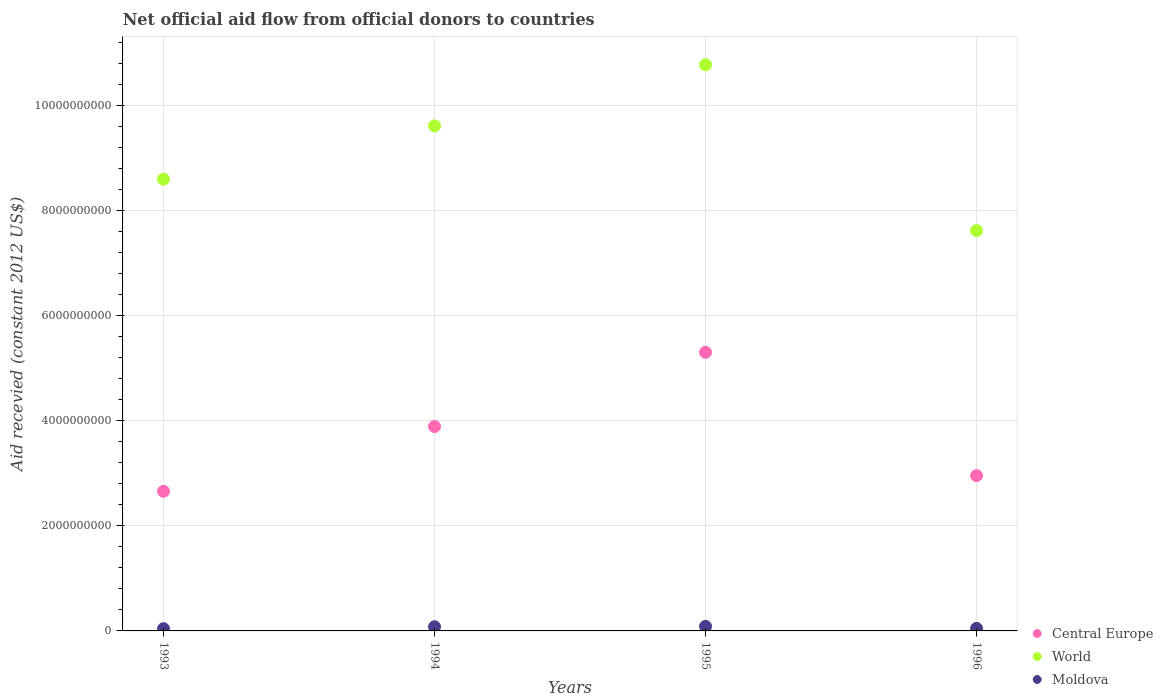How many different coloured dotlines are there?
Give a very brief answer. 3. What is the total aid received in Moldova in 1995?
Offer a very short reply. 8.72e+07. Across all years, what is the maximum total aid received in Moldova?
Make the answer very short. 8.72e+07. Across all years, what is the minimum total aid received in World?
Make the answer very short. 7.62e+09. In which year was the total aid received in World maximum?
Ensure brevity in your answer.  1995. In which year was the total aid received in World minimum?
Offer a very short reply. 1996. What is the total total aid received in World in the graph?
Your response must be concise. 3.66e+1. What is the difference between the total aid received in Central Europe in 1993 and that in 1996?
Make the answer very short. -2.98e+08. What is the difference between the total aid received in World in 1993 and the total aid received in Central Europe in 1994?
Ensure brevity in your answer.  4.71e+09. What is the average total aid received in Central Europe per year?
Give a very brief answer. 3.70e+09. In the year 1994, what is the difference between the total aid received in Moldova and total aid received in Central Europe?
Your answer should be compact. -3.81e+09. In how many years, is the total aid received in Central Europe greater than 3200000000 US$?
Your answer should be compact. 2. What is the ratio of the total aid received in World in 1994 to that in 1996?
Offer a terse response. 1.26. What is the difference between the highest and the second highest total aid received in Central Europe?
Offer a terse response. 1.41e+09. What is the difference between the highest and the lowest total aid received in Moldova?
Your response must be concise. 4.48e+07. In how many years, is the total aid received in Moldova greater than the average total aid received in Moldova taken over all years?
Ensure brevity in your answer.  2. Is the sum of the total aid received in World in 1993 and 1996 greater than the maximum total aid received in Moldova across all years?
Offer a very short reply. Yes. Does the total aid received in Moldova monotonically increase over the years?
Offer a very short reply. No. Is the total aid received in Central Europe strictly greater than the total aid received in Moldova over the years?
Offer a very short reply. Yes. How many years are there in the graph?
Your answer should be compact. 4. What is the difference between two consecutive major ticks on the Y-axis?
Keep it short and to the point. 2.00e+09. Are the values on the major ticks of Y-axis written in scientific E-notation?
Keep it short and to the point. No. Does the graph contain grids?
Offer a terse response. Yes. Where does the legend appear in the graph?
Your answer should be very brief. Bottom right. How many legend labels are there?
Provide a short and direct response. 3. How are the legend labels stacked?
Your answer should be compact. Vertical. What is the title of the graph?
Your answer should be very brief. Net official aid flow from official donors to countries. What is the label or title of the Y-axis?
Give a very brief answer. Aid recevied (constant 2012 US$). What is the Aid recevied (constant 2012 US$) in Central Europe in 1993?
Provide a short and direct response. 2.66e+09. What is the Aid recevied (constant 2012 US$) in World in 1993?
Make the answer very short. 8.60e+09. What is the Aid recevied (constant 2012 US$) in Moldova in 1993?
Your response must be concise. 4.23e+07. What is the Aid recevied (constant 2012 US$) in Central Europe in 1994?
Provide a succinct answer. 3.89e+09. What is the Aid recevied (constant 2012 US$) of World in 1994?
Your response must be concise. 9.61e+09. What is the Aid recevied (constant 2012 US$) in Moldova in 1994?
Ensure brevity in your answer.  7.92e+07. What is the Aid recevied (constant 2012 US$) of Central Europe in 1995?
Ensure brevity in your answer.  5.30e+09. What is the Aid recevied (constant 2012 US$) of World in 1995?
Your answer should be compact. 1.08e+1. What is the Aid recevied (constant 2012 US$) of Moldova in 1995?
Offer a very short reply. 8.72e+07. What is the Aid recevied (constant 2012 US$) in Central Europe in 1996?
Provide a succinct answer. 2.96e+09. What is the Aid recevied (constant 2012 US$) in World in 1996?
Give a very brief answer. 7.62e+09. What is the Aid recevied (constant 2012 US$) in Moldova in 1996?
Your answer should be very brief. 4.89e+07. Across all years, what is the maximum Aid recevied (constant 2012 US$) of Central Europe?
Make the answer very short. 5.30e+09. Across all years, what is the maximum Aid recevied (constant 2012 US$) of World?
Give a very brief answer. 1.08e+1. Across all years, what is the maximum Aid recevied (constant 2012 US$) in Moldova?
Provide a short and direct response. 8.72e+07. Across all years, what is the minimum Aid recevied (constant 2012 US$) in Central Europe?
Provide a short and direct response. 2.66e+09. Across all years, what is the minimum Aid recevied (constant 2012 US$) of World?
Your answer should be very brief. 7.62e+09. Across all years, what is the minimum Aid recevied (constant 2012 US$) of Moldova?
Keep it short and to the point. 4.23e+07. What is the total Aid recevied (constant 2012 US$) in Central Europe in the graph?
Provide a short and direct response. 1.48e+1. What is the total Aid recevied (constant 2012 US$) in World in the graph?
Give a very brief answer. 3.66e+1. What is the total Aid recevied (constant 2012 US$) in Moldova in the graph?
Provide a succinct answer. 2.57e+08. What is the difference between the Aid recevied (constant 2012 US$) in Central Europe in 1993 and that in 1994?
Give a very brief answer. -1.23e+09. What is the difference between the Aid recevied (constant 2012 US$) in World in 1993 and that in 1994?
Provide a short and direct response. -1.01e+09. What is the difference between the Aid recevied (constant 2012 US$) of Moldova in 1993 and that in 1994?
Offer a terse response. -3.68e+07. What is the difference between the Aid recevied (constant 2012 US$) of Central Europe in 1993 and that in 1995?
Provide a succinct answer. -2.64e+09. What is the difference between the Aid recevied (constant 2012 US$) of World in 1993 and that in 1995?
Your answer should be compact. -2.18e+09. What is the difference between the Aid recevied (constant 2012 US$) in Moldova in 1993 and that in 1995?
Your response must be concise. -4.48e+07. What is the difference between the Aid recevied (constant 2012 US$) in Central Europe in 1993 and that in 1996?
Offer a very short reply. -2.98e+08. What is the difference between the Aid recevied (constant 2012 US$) in World in 1993 and that in 1996?
Your response must be concise. 9.79e+08. What is the difference between the Aid recevied (constant 2012 US$) of Moldova in 1993 and that in 1996?
Make the answer very short. -6.56e+06. What is the difference between the Aid recevied (constant 2012 US$) in Central Europe in 1994 and that in 1995?
Provide a succinct answer. -1.41e+09. What is the difference between the Aid recevied (constant 2012 US$) in World in 1994 and that in 1995?
Offer a very short reply. -1.16e+09. What is the difference between the Aid recevied (constant 2012 US$) in Moldova in 1994 and that in 1995?
Keep it short and to the point. -8.00e+06. What is the difference between the Aid recevied (constant 2012 US$) of Central Europe in 1994 and that in 1996?
Provide a succinct answer. 9.34e+08. What is the difference between the Aid recevied (constant 2012 US$) of World in 1994 and that in 1996?
Offer a very short reply. 1.99e+09. What is the difference between the Aid recevied (constant 2012 US$) of Moldova in 1994 and that in 1996?
Ensure brevity in your answer.  3.03e+07. What is the difference between the Aid recevied (constant 2012 US$) in Central Europe in 1995 and that in 1996?
Make the answer very short. 2.35e+09. What is the difference between the Aid recevied (constant 2012 US$) in World in 1995 and that in 1996?
Keep it short and to the point. 3.16e+09. What is the difference between the Aid recevied (constant 2012 US$) in Moldova in 1995 and that in 1996?
Offer a terse response. 3.83e+07. What is the difference between the Aid recevied (constant 2012 US$) of Central Europe in 1993 and the Aid recevied (constant 2012 US$) of World in 1994?
Provide a short and direct response. -6.95e+09. What is the difference between the Aid recevied (constant 2012 US$) of Central Europe in 1993 and the Aid recevied (constant 2012 US$) of Moldova in 1994?
Offer a very short reply. 2.58e+09. What is the difference between the Aid recevied (constant 2012 US$) of World in 1993 and the Aid recevied (constant 2012 US$) of Moldova in 1994?
Offer a very short reply. 8.52e+09. What is the difference between the Aid recevied (constant 2012 US$) of Central Europe in 1993 and the Aid recevied (constant 2012 US$) of World in 1995?
Provide a succinct answer. -8.12e+09. What is the difference between the Aid recevied (constant 2012 US$) of Central Europe in 1993 and the Aid recevied (constant 2012 US$) of Moldova in 1995?
Ensure brevity in your answer.  2.57e+09. What is the difference between the Aid recevied (constant 2012 US$) of World in 1993 and the Aid recevied (constant 2012 US$) of Moldova in 1995?
Keep it short and to the point. 8.51e+09. What is the difference between the Aid recevied (constant 2012 US$) in Central Europe in 1993 and the Aid recevied (constant 2012 US$) in World in 1996?
Make the answer very short. -4.96e+09. What is the difference between the Aid recevied (constant 2012 US$) in Central Europe in 1993 and the Aid recevied (constant 2012 US$) in Moldova in 1996?
Keep it short and to the point. 2.61e+09. What is the difference between the Aid recevied (constant 2012 US$) in World in 1993 and the Aid recevied (constant 2012 US$) in Moldova in 1996?
Provide a short and direct response. 8.55e+09. What is the difference between the Aid recevied (constant 2012 US$) of Central Europe in 1994 and the Aid recevied (constant 2012 US$) of World in 1995?
Your answer should be very brief. -6.89e+09. What is the difference between the Aid recevied (constant 2012 US$) in Central Europe in 1994 and the Aid recevied (constant 2012 US$) in Moldova in 1995?
Offer a very short reply. 3.80e+09. What is the difference between the Aid recevied (constant 2012 US$) in World in 1994 and the Aid recevied (constant 2012 US$) in Moldova in 1995?
Offer a very short reply. 9.52e+09. What is the difference between the Aid recevied (constant 2012 US$) in Central Europe in 1994 and the Aid recevied (constant 2012 US$) in World in 1996?
Ensure brevity in your answer.  -3.73e+09. What is the difference between the Aid recevied (constant 2012 US$) in Central Europe in 1994 and the Aid recevied (constant 2012 US$) in Moldova in 1996?
Ensure brevity in your answer.  3.84e+09. What is the difference between the Aid recevied (constant 2012 US$) of World in 1994 and the Aid recevied (constant 2012 US$) of Moldova in 1996?
Your answer should be very brief. 9.56e+09. What is the difference between the Aid recevied (constant 2012 US$) in Central Europe in 1995 and the Aid recevied (constant 2012 US$) in World in 1996?
Make the answer very short. -2.32e+09. What is the difference between the Aid recevied (constant 2012 US$) of Central Europe in 1995 and the Aid recevied (constant 2012 US$) of Moldova in 1996?
Make the answer very short. 5.25e+09. What is the difference between the Aid recevied (constant 2012 US$) in World in 1995 and the Aid recevied (constant 2012 US$) in Moldova in 1996?
Your answer should be very brief. 1.07e+1. What is the average Aid recevied (constant 2012 US$) of Central Europe per year?
Offer a very short reply. 3.70e+09. What is the average Aid recevied (constant 2012 US$) in World per year?
Provide a short and direct response. 9.15e+09. What is the average Aid recevied (constant 2012 US$) of Moldova per year?
Give a very brief answer. 6.44e+07. In the year 1993, what is the difference between the Aid recevied (constant 2012 US$) of Central Europe and Aid recevied (constant 2012 US$) of World?
Keep it short and to the point. -5.94e+09. In the year 1993, what is the difference between the Aid recevied (constant 2012 US$) in Central Europe and Aid recevied (constant 2012 US$) in Moldova?
Your response must be concise. 2.62e+09. In the year 1993, what is the difference between the Aid recevied (constant 2012 US$) of World and Aid recevied (constant 2012 US$) of Moldova?
Your answer should be very brief. 8.55e+09. In the year 1994, what is the difference between the Aid recevied (constant 2012 US$) of Central Europe and Aid recevied (constant 2012 US$) of World?
Provide a short and direct response. -5.72e+09. In the year 1994, what is the difference between the Aid recevied (constant 2012 US$) of Central Europe and Aid recevied (constant 2012 US$) of Moldova?
Your response must be concise. 3.81e+09. In the year 1994, what is the difference between the Aid recevied (constant 2012 US$) of World and Aid recevied (constant 2012 US$) of Moldova?
Your response must be concise. 9.53e+09. In the year 1995, what is the difference between the Aid recevied (constant 2012 US$) in Central Europe and Aid recevied (constant 2012 US$) in World?
Offer a very short reply. -5.47e+09. In the year 1995, what is the difference between the Aid recevied (constant 2012 US$) in Central Europe and Aid recevied (constant 2012 US$) in Moldova?
Keep it short and to the point. 5.21e+09. In the year 1995, what is the difference between the Aid recevied (constant 2012 US$) in World and Aid recevied (constant 2012 US$) in Moldova?
Offer a very short reply. 1.07e+1. In the year 1996, what is the difference between the Aid recevied (constant 2012 US$) of Central Europe and Aid recevied (constant 2012 US$) of World?
Make the answer very short. -4.66e+09. In the year 1996, what is the difference between the Aid recevied (constant 2012 US$) in Central Europe and Aid recevied (constant 2012 US$) in Moldova?
Make the answer very short. 2.91e+09. In the year 1996, what is the difference between the Aid recevied (constant 2012 US$) in World and Aid recevied (constant 2012 US$) in Moldova?
Give a very brief answer. 7.57e+09. What is the ratio of the Aid recevied (constant 2012 US$) of Central Europe in 1993 to that in 1994?
Give a very brief answer. 0.68. What is the ratio of the Aid recevied (constant 2012 US$) of World in 1993 to that in 1994?
Give a very brief answer. 0.89. What is the ratio of the Aid recevied (constant 2012 US$) in Moldova in 1993 to that in 1994?
Make the answer very short. 0.53. What is the ratio of the Aid recevied (constant 2012 US$) of Central Europe in 1993 to that in 1995?
Your answer should be very brief. 0.5. What is the ratio of the Aid recevied (constant 2012 US$) of World in 1993 to that in 1995?
Offer a terse response. 0.8. What is the ratio of the Aid recevied (constant 2012 US$) of Moldova in 1993 to that in 1995?
Offer a very short reply. 0.49. What is the ratio of the Aid recevied (constant 2012 US$) of Central Europe in 1993 to that in 1996?
Make the answer very short. 0.9. What is the ratio of the Aid recevied (constant 2012 US$) in World in 1993 to that in 1996?
Offer a terse response. 1.13. What is the ratio of the Aid recevied (constant 2012 US$) in Moldova in 1993 to that in 1996?
Offer a terse response. 0.87. What is the ratio of the Aid recevied (constant 2012 US$) of Central Europe in 1994 to that in 1995?
Your answer should be very brief. 0.73. What is the ratio of the Aid recevied (constant 2012 US$) of World in 1994 to that in 1995?
Provide a short and direct response. 0.89. What is the ratio of the Aid recevied (constant 2012 US$) in Moldova in 1994 to that in 1995?
Your answer should be very brief. 0.91. What is the ratio of the Aid recevied (constant 2012 US$) of Central Europe in 1994 to that in 1996?
Your answer should be very brief. 1.32. What is the ratio of the Aid recevied (constant 2012 US$) in World in 1994 to that in 1996?
Your answer should be very brief. 1.26. What is the ratio of the Aid recevied (constant 2012 US$) of Moldova in 1994 to that in 1996?
Make the answer very short. 1.62. What is the ratio of the Aid recevied (constant 2012 US$) of Central Europe in 1995 to that in 1996?
Ensure brevity in your answer.  1.79. What is the ratio of the Aid recevied (constant 2012 US$) of World in 1995 to that in 1996?
Provide a short and direct response. 1.41. What is the ratio of the Aid recevied (constant 2012 US$) in Moldova in 1995 to that in 1996?
Ensure brevity in your answer.  1.78. What is the difference between the highest and the second highest Aid recevied (constant 2012 US$) in Central Europe?
Ensure brevity in your answer.  1.41e+09. What is the difference between the highest and the second highest Aid recevied (constant 2012 US$) of World?
Provide a short and direct response. 1.16e+09. What is the difference between the highest and the second highest Aid recevied (constant 2012 US$) in Moldova?
Offer a very short reply. 8.00e+06. What is the difference between the highest and the lowest Aid recevied (constant 2012 US$) in Central Europe?
Your response must be concise. 2.64e+09. What is the difference between the highest and the lowest Aid recevied (constant 2012 US$) of World?
Make the answer very short. 3.16e+09. What is the difference between the highest and the lowest Aid recevied (constant 2012 US$) in Moldova?
Provide a succinct answer. 4.48e+07. 